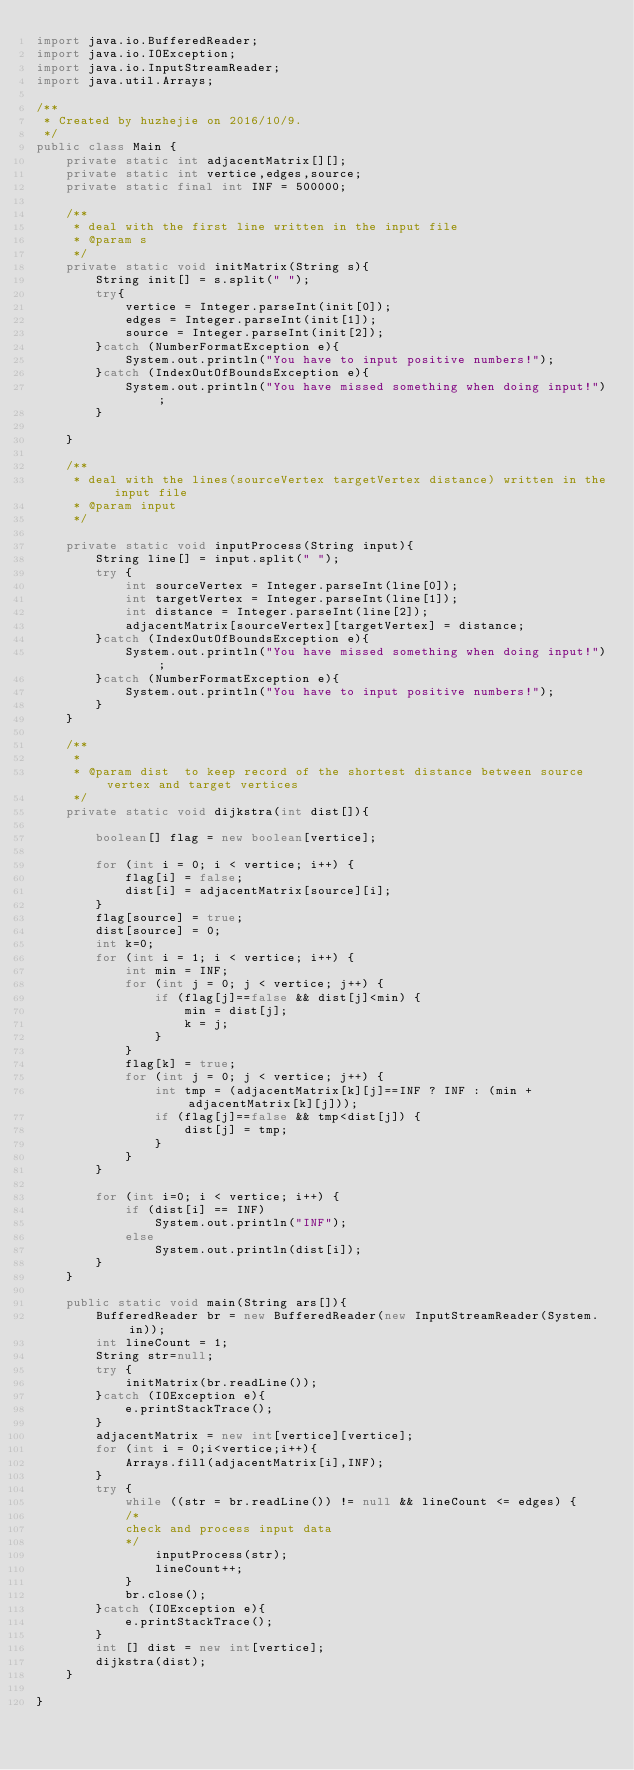<code> <loc_0><loc_0><loc_500><loc_500><_Java_>import java.io.BufferedReader;
import java.io.IOException;
import java.io.InputStreamReader;
import java.util.Arrays;

/**
 * Created by huzhejie on 2016/10/9.
 */
public class Main {
    private static int adjacentMatrix[][];
    private static int vertice,edges,source;
    private static final int INF = 500000;

    /**
     * deal with the first line written in the input file
     * @param s
     */
    private static void initMatrix(String s){
        String init[] = s.split(" ");
        try{
            vertice = Integer.parseInt(init[0]);
            edges = Integer.parseInt(init[1]);
            source = Integer.parseInt(init[2]);
        }catch (NumberFormatException e){
            System.out.println("You have to input positive numbers!");
        }catch (IndexOutOfBoundsException e){
            System.out.println("You have missed something when doing input!");
        }

    }

    /**
     * deal with the lines(sourceVertex targetVertex distance) written in the input file
     * @param input
     */

    private static void inputProcess(String input){
        String line[] = input.split(" ");
        try {
            int sourceVertex = Integer.parseInt(line[0]);
            int targetVertex = Integer.parseInt(line[1]);
            int distance = Integer.parseInt(line[2]);
            adjacentMatrix[sourceVertex][targetVertex] = distance;
        }catch (IndexOutOfBoundsException e){
            System.out.println("You have missed something when doing input!");
        }catch (NumberFormatException e){
            System.out.println("You have to input positive numbers!");
        }
    }

    /**
     *
     * @param dist  to keep record of the shortest distance between source vertex and target vertices
     */
    private static void dijkstra(int dist[]){

        boolean[] flag = new boolean[vertice];

        for (int i = 0; i < vertice; i++) {
            flag[i] = false;
            dist[i] = adjacentMatrix[source][i];
        }
        flag[source] = true;
        dist[source] = 0;
        int k=0;
        for (int i = 1; i < vertice; i++) {
            int min = INF;
            for (int j = 0; j < vertice; j++) {
                if (flag[j]==false && dist[j]<min) {
                    min = dist[j];
                    k = j;
                }
            }
            flag[k] = true;
            for (int j = 0; j < vertice; j++) {
                int tmp = (adjacentMatrix[k][j]==INF ? INF : (min + adjacentMatrix[k][j]));
                if (flag[j]==false && tmp<dist[j]) {
                    dist[j] = tmp;
                }
            }
        }

        for (int i=0; i < vertice; i++) {
            if (dist[i] == INF)
                System.out.println("INF");
            else
                System.out.println(dist[i]);
        }
    }

    public static void main(String ars[]){
        BufferedReader br = new BufferedReader(new InputStreamReader(System.in));
        int lineCount = 1;
        String str=null;
        try {
            initMatrix(br.readLine());
        }catch (IOException e){
            e.printStackTrace();
        }
        adjacentMatrix = new int[vertice][vertice];
        for (int i = 0;i<vertice;i++){
            Arrays.fill(adjacentMatrix[i],INF);
        }
        try {
            while ((str = br.readLine()) != null && lineCount <= edges) {
            /*
            check and process input data
            */
                inputProcess(str);
                lineCount++;
            }
            br.close();
        }catch (IOException e){
            e.printStackTrace();
        }
        int [] dist = new int[vertice];
        dijkstra(dist);
    }

}</code> 